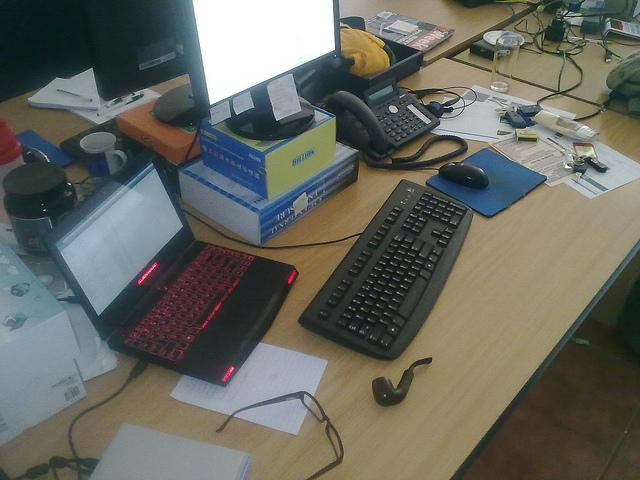What type of phone can this person use at the desk?

Choices:
A) cellular
B) landline
C) payphone
D) rotary landline 